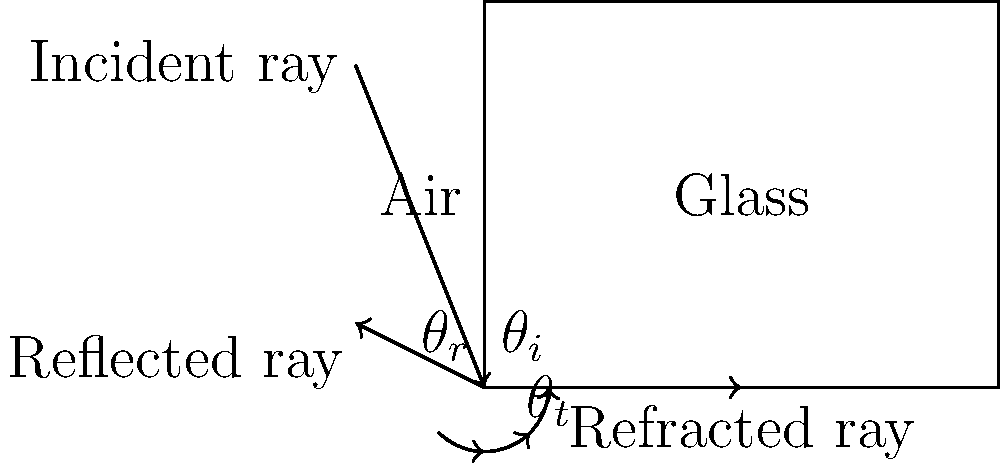In the context of religious architecture, stained glass windows often play a significant role in creating a spiritual atmosphere. Consider the diagram showing light interacting with a stained glass window. If the incident angle $\theta_i$ is 45°, the refractive index of air is 1.0, and the refractive index of the glass is 1.5, what is the angle of refraction $\theta_t$? To solve this problem, we'll use Snell's law, which describes the relationship between the angles of incidence and refraction for light passing through different media:

1) Snell's law states: $n_1 \sin(\theta_1) = n_2 \sin(\theta_2)$

   Where:
   $n_1$ is the refractive index of the first medium (air)
   $n_2$ is the refractive index of the second medium (glass)
   $\theta_1$ is the angle of incidence
   $\theta_2$ is the angle of refraction

2) We're given:
   $n_1 = 1.0$ (air)
   $n_2 = 1.5$ (glass)
   $\theta_1 = 45°$

3) Substituting these values into Snell's law:

   $1.0 \sin(45°) = 1.5 \sin(\theta_t)$

4) Simplify:
   $\sin(45°) = 1.5 \sin(\theta_t)$

5) $\sin(45°) = \frac{\sqrt{2}}{2} \approx 0.7071$

6) So our equation becomes:
   $0.7071 = 1.5 \sin(\theta_t)$

7) Solve for $\sin(\theta_t)$:
   $\sin(\theta_t) = \frac{0.7071}{1.5} \approx 0.4714$

8) Take the inverse sine (arcsin) of both sides:
   $\theta_t = \arcsin(0.4714) \approx 28.1°$

Therefore, the angle of refraction is approximately 28.1°.
Answer: 28.1° 